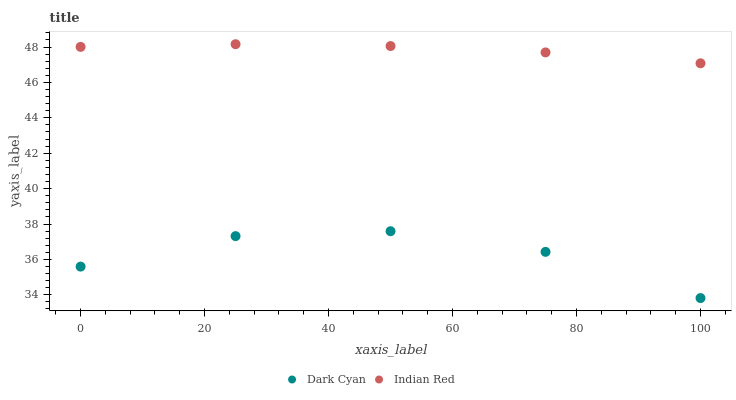Does Dark Cyan have the minimum area under the curve?
Answer yes or no. Yes. Does Indian Red have the maximum area under the curve?
Answer yes or no. Yes. Does Indian Red have the minimum area under the curve?
Answer yes or no. No. Is Indian Red the smoothest?
Answer yes or no. Yes. Is Dark Cyan the roughest?
Answer yes or no. Yes. Is Indian Red the roughest?
Answer yes or no. No. Does Dark Cyan have the lowest value?
Answer yes or no. Yes. Does Indian Red have the lowest value?
Answer yes or no. No. Does Indian Red have the highest value?
Answer yes or no. Yes. Is Dark Cyan less than Indian Red?
Answer yes or no. Yes. Is Indian Red greater than Dark Cyan?
Answer yes or no. Yes. Does Dark Cyan intersect Indian Red?
Answer yes or no. No. 